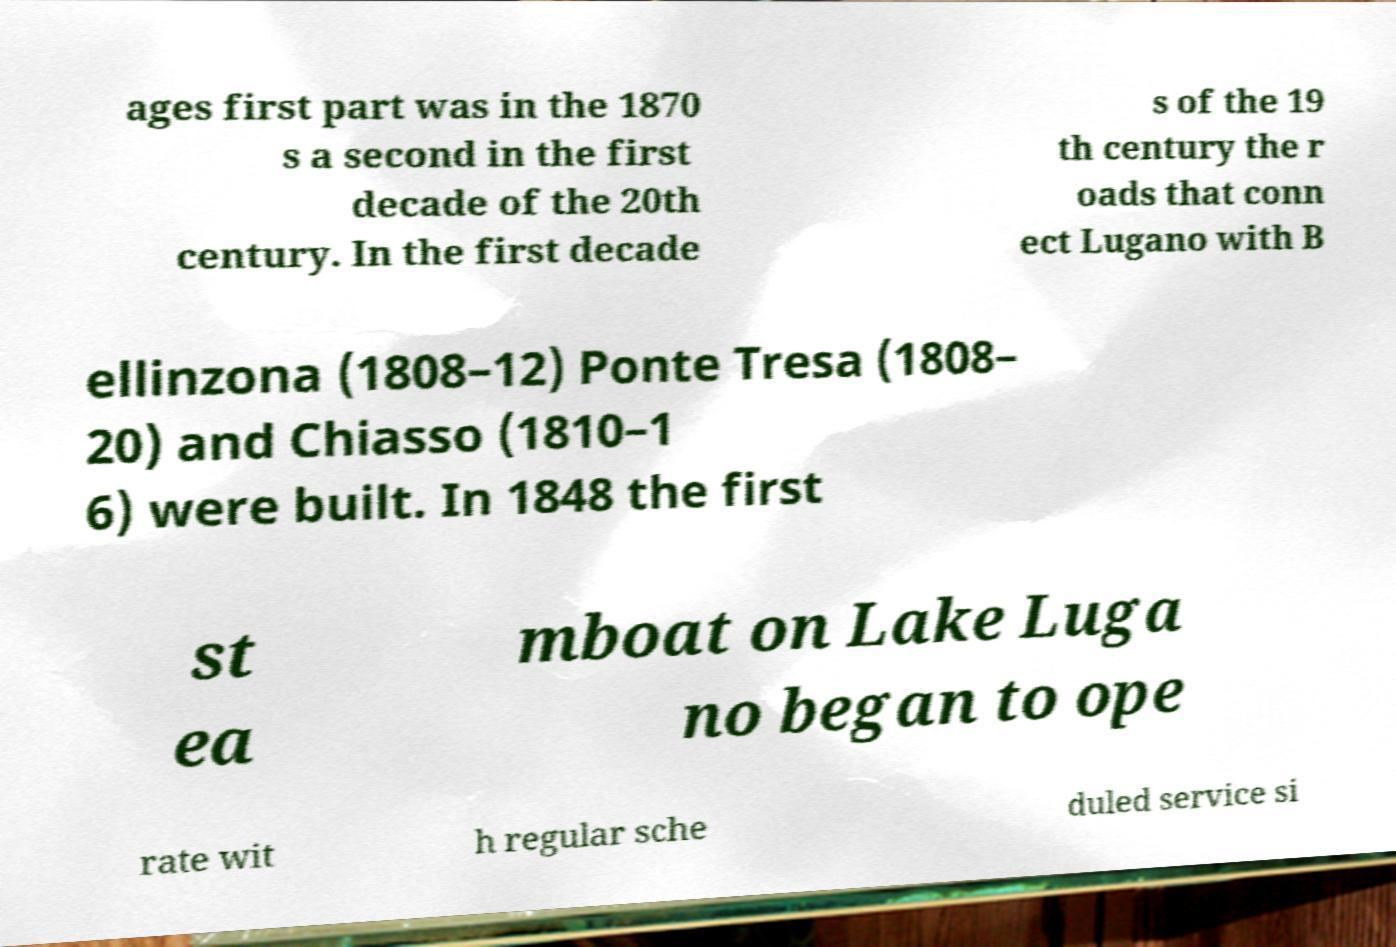For documentation purposes, I need the text within this image transcribed. Could you provide that? ages first part was in the 1870 s a second in the first decade of the 20th century. In the first decade s of the 19 th century the r oads that conn ect Lugano with B ellinzona (1808–12) Ponte Tresa (1808– 20) and Chiasso (1810–1 6) were built. In 1848 the first st ea mboat on Lake Luga no began to ope rate wit h regular sche duled service si 